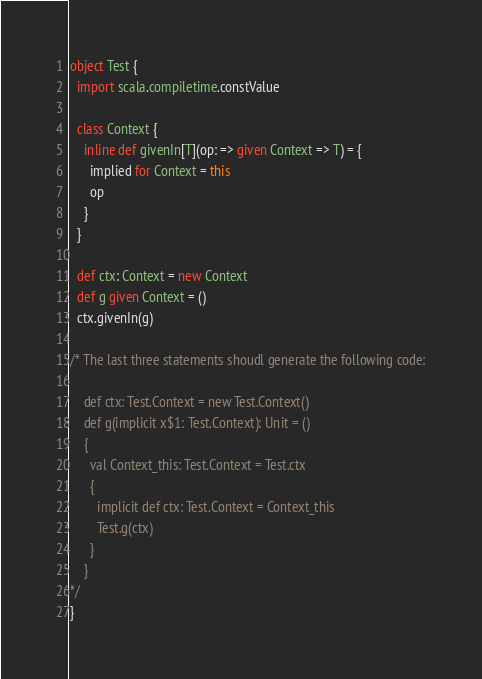<code> <loc_0><loc_0><loc_500><loc_500><_Scala_>object Test {
  import scala.compiletime.constValue

  class Context {
    inline def givenIn[T](op: => given Context => T) = {
      implied for Context = this
      op
    }
  }

  def ctx: Context = new Context
  def g given Context = ()
  ctx.givenIn(g)

/* The last three statements shoudl generate the following code:

    def ctx: Test.Context = new Test.Context()
    def g(implicit x$1: Test.Context): Unit = ()
    {
      val Context_this: Test.Context = Test.ctx
      {
        implicit def ctx: Test.Context = Context_this
        Test.g(ctx)
      }
    }
*/
}
</code> 